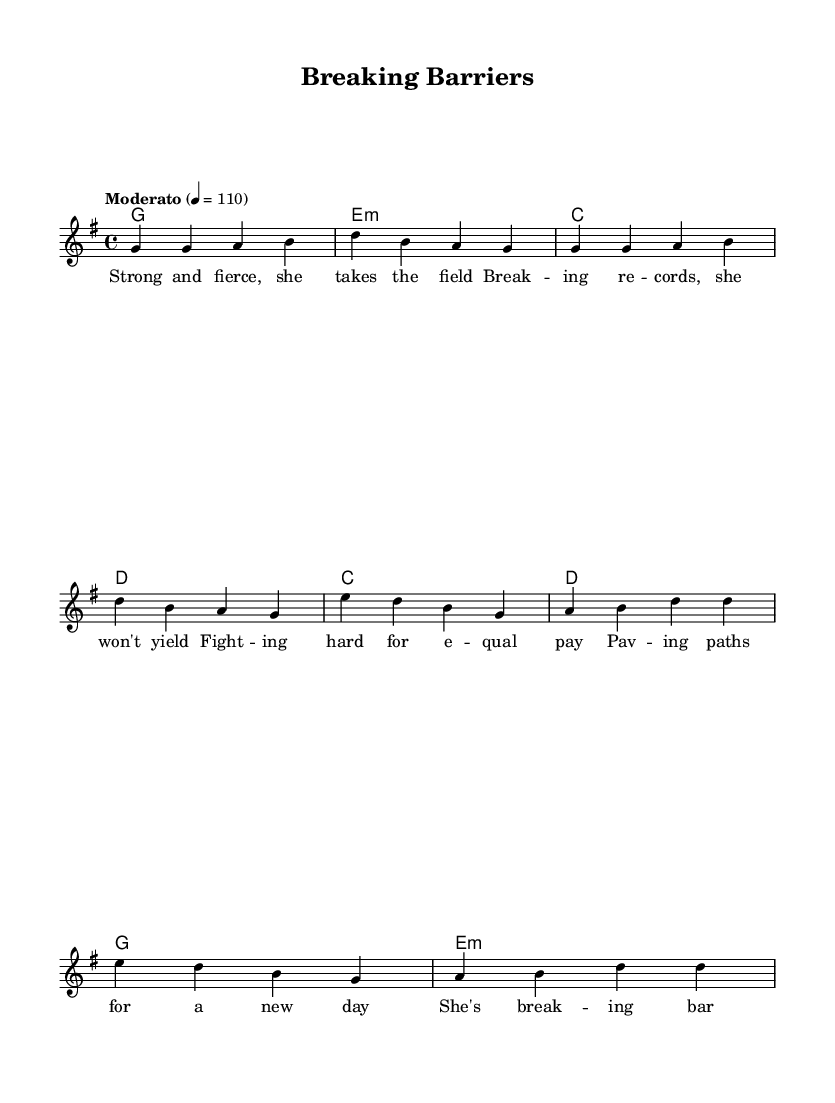What is the key signature of this music? The key signature is G major, indicated by one sharp (F#) at the beginning of the staff.
Answer: G major What is the time signature of this music? The time signature is 4/4, shown at the beginning of the piece with a fraction indicating four beats per measure.
Answer: 4/4 What is the tempo marking for this piece? The tempo marking is "Moderato," which indicates a moderate speed, set at a metronome mark of quarter note equals 110 beats per minute.
Answer: Moderato How many measures are there in the verse? The verse consists of four measures, with each line having two measures, totaling four for the entire verse section.
Answer: Four What musical section follows the verse? The musical section that follows the verse is the chorus, as indicated by the structure of the lyrics and the progression of the music.
Answer: Chorus What type of chords are predominantly used in the harmonies? The predominant chords used in the harmonies are major and minor chords, specifically G major, E minor, C major, and D major, which give the piece its R&B feel.
Answer: Major and minor chords What theme does the lyrics focus on? The lyrics focus on themes of empowerment and breaking barriers for women athletes, celebrating their achievements and striving for equal pay.
Answer: Empowerment and equal pay 